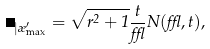Convert formula to latex. <formula><loc_0><loc_0><loc_500><loc_500>\Lambda _ { | \rho _ { \max } ^ { \prime } } = \sqrt { r ^ { 2 } + 1 } \frac { t } { \epsilon } N ( \epsilon , t ) ,</formula> 